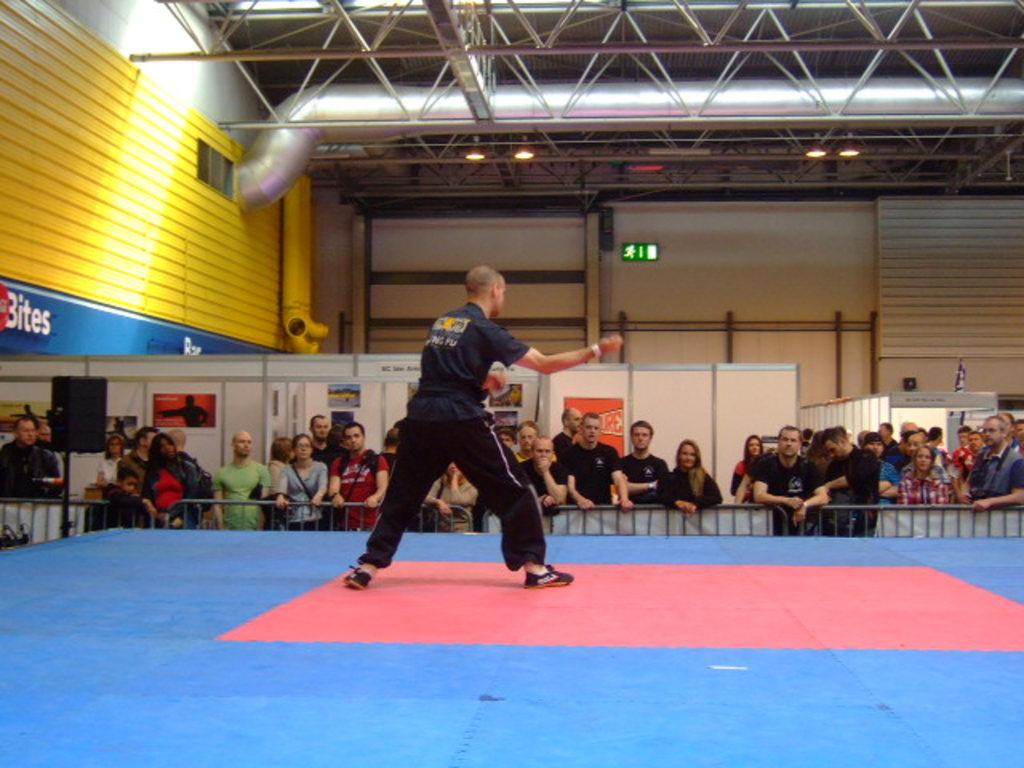What is the main subject of the image? There is a person standing on a stage in the image. Are there any other people present in the image? Yes, there are spectators in the image. What are the spectators doing in the image? The spectators are watching the person on the stage. What is the rate at which the person's foot is moving in the image? There is no information about the person's foot movement in the image, so it cannot be determined. 